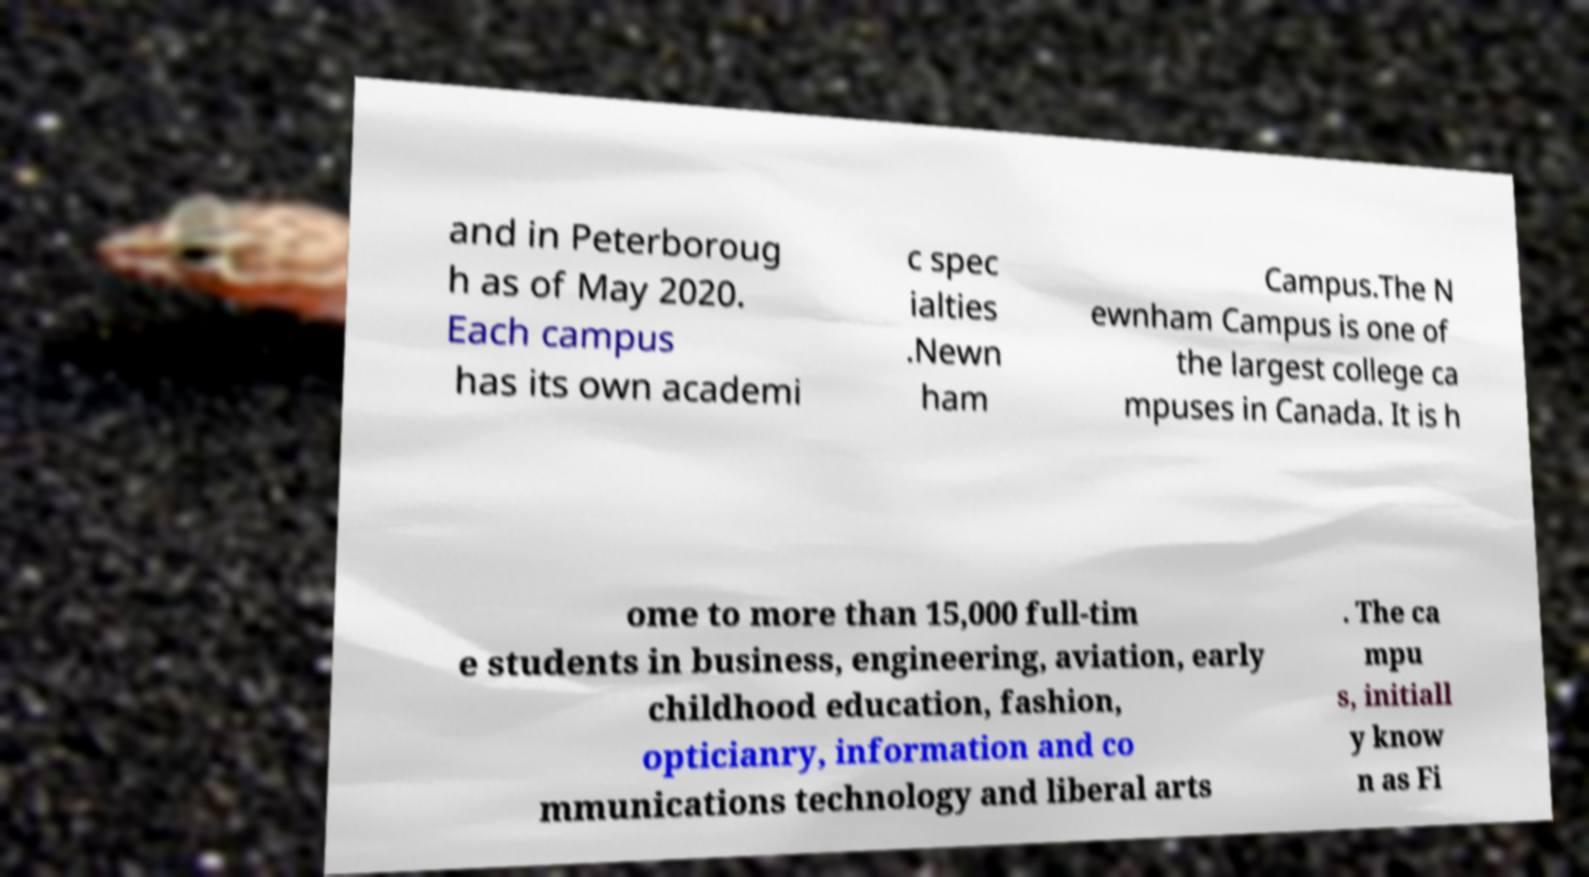Could you assist in decoding the text presented in this image and type it out clearly? and in Peterboroug h as of May 2020. Each campus has its own academi c spec ialties .Newn ham Campus.The N ewnham Campus is one of the largest college ca mpuses in Canada. It is h ome to more than 15,000 full-tim e students in business, engineering, aviation, early childhood education, fashion, opticianry, information and co mmunications technology and liberal arts . The ca mpu s, initiall y know n as Fi 